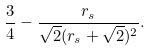Convert formula to latex. <formula><loc_0><loc_0><loc_500><loc_500>\frac { 3 } { 4 } - \frac { r _ { s } } { \sqrt { 2 } ( r _ { s } + \sqrt { 2 } ) ^ { 2 } } .</formula> 